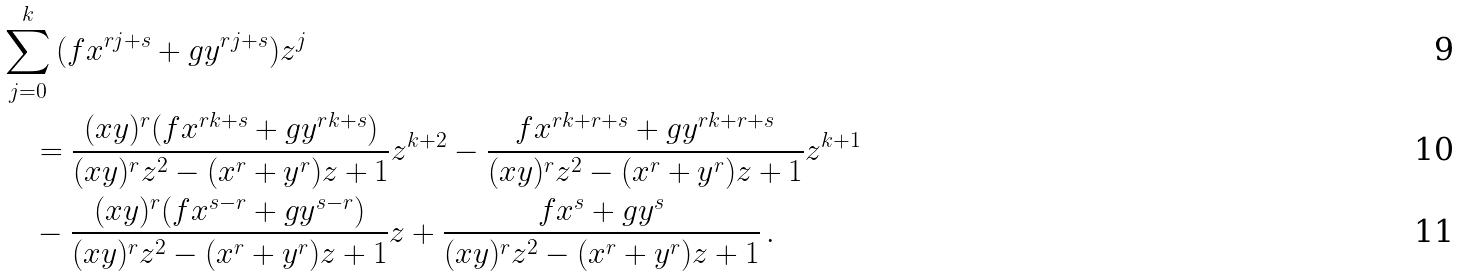<formula> <loc_0><loc_0><loc_500><loc_500>& \sum _ { j = 0 } ^ { k } { ( f x ^ { r j + s } + g y ^ { r j + s } ) z ^ { j } } \\ & \quad = \frac { ( x y ) ^ { r } ( f x ^ { r k + s } + g y ^ { r k + s } ) } { ( x y ) ^ { r } z ^ { 2 } - ( x ^ { r } + y ^ { r } ) z + 1 } z ^ { k + 2 } - \frac { f x ^ { r k + r + s } + g y ^ { r k + r + s } } { ( x y ) ^ { r } z ^ { 2 } - ( x ^ { r } + y ^ { r } ) z + 1 } z ^ { k + 1 } \\ & \quad - \frac { ( x y ) ^ { r } ( f x ^ { s - r } + g y ^ { s - r } ) } { ( x y ) ^ { r } z ^ { 2 } - ( x ^ { r } + y ^ { r } ) z + 1 } z + \frac { f x ^ { s } + g y ^ { s } } { ( x y ) ^ { r } z ^ { 2 } - ( x ^ { r } + y ^ { r } ) z + 1 } \, .</formula> 